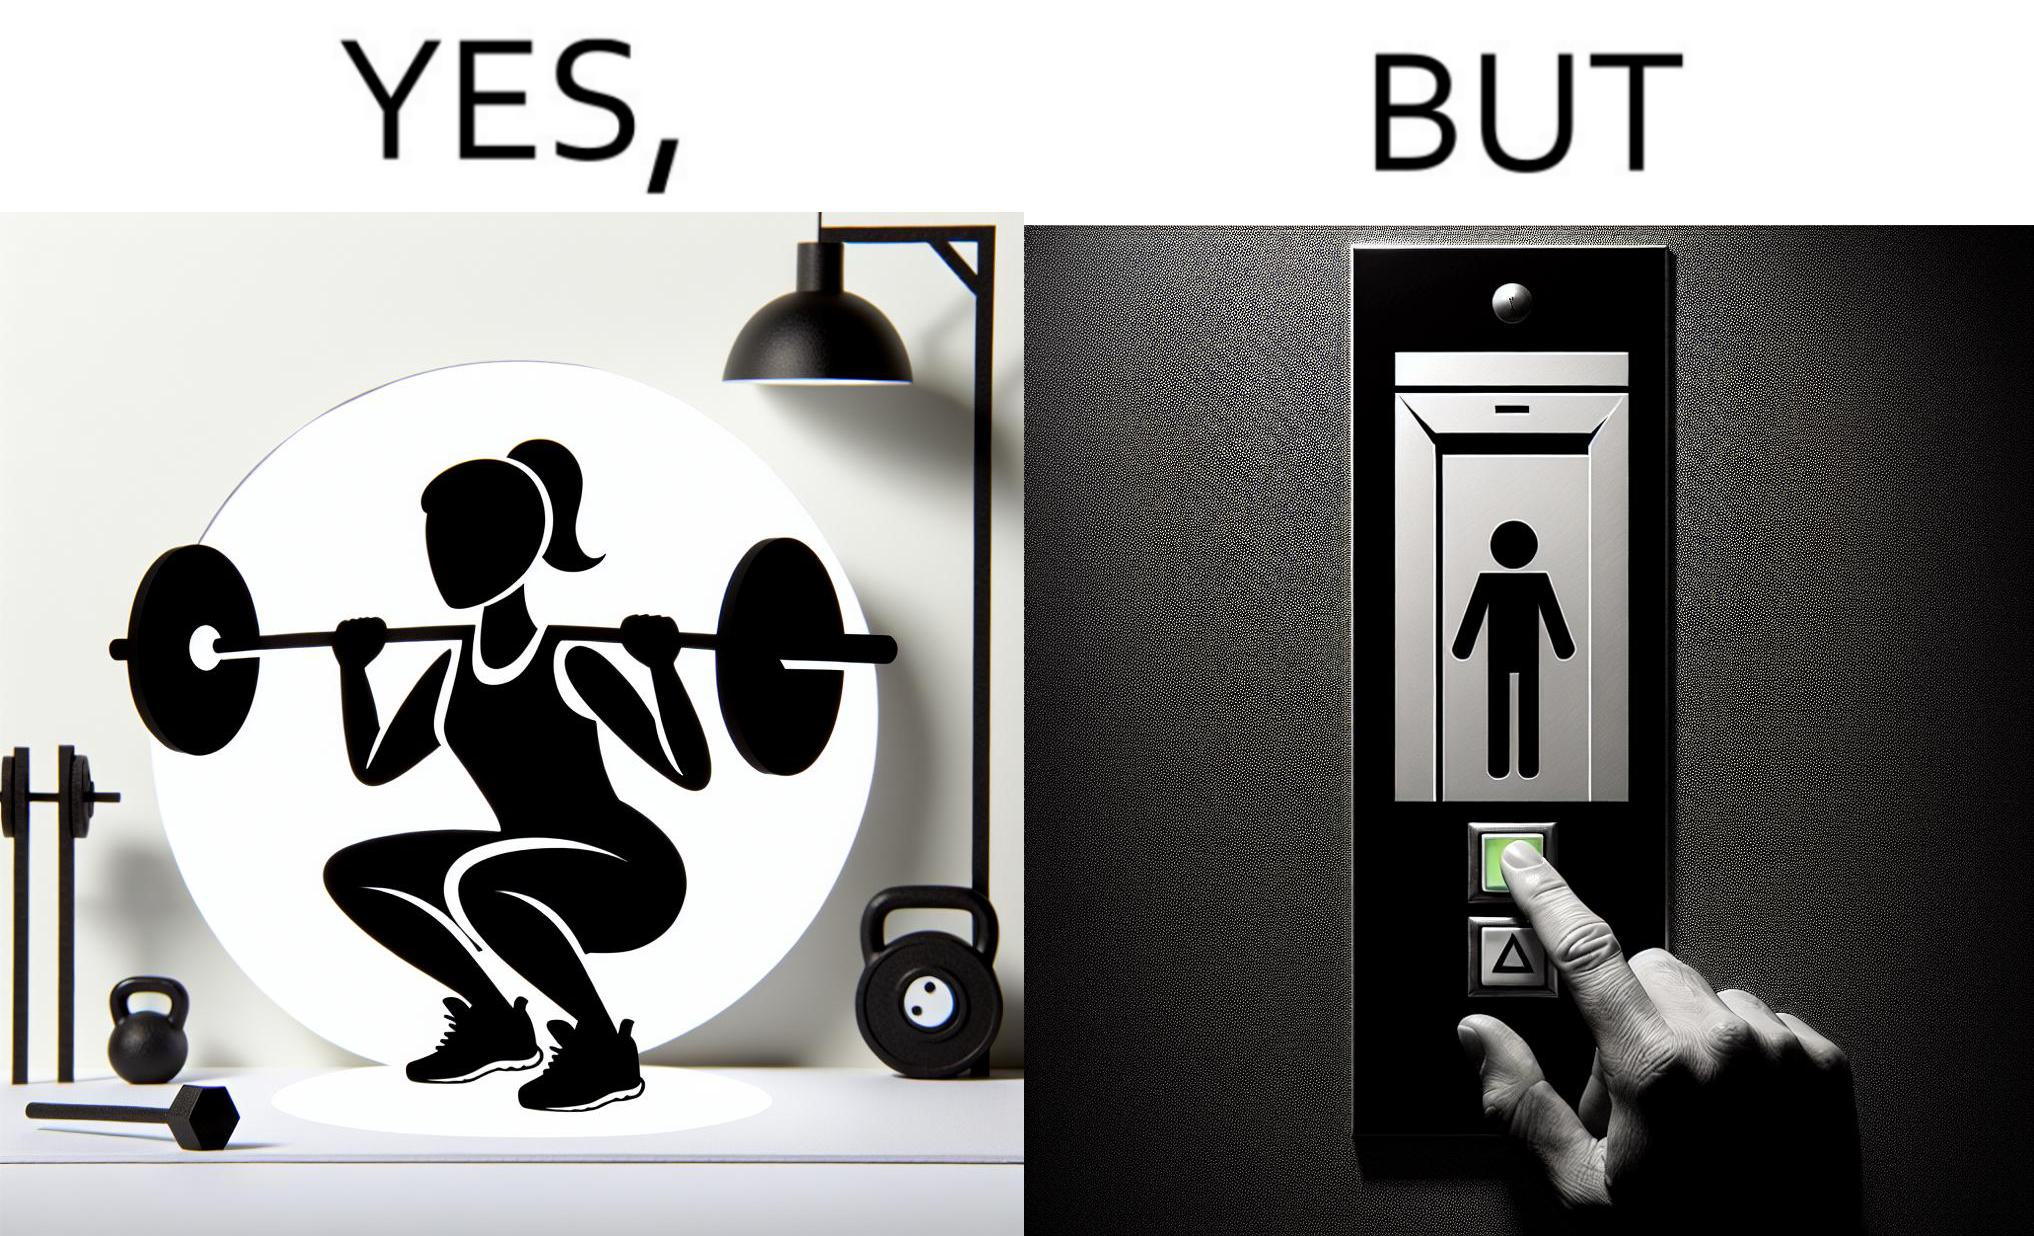Compare the left and right sides of this image. In the left part of the image: The image shows a women exercising with a bar bell in a gym. She is wearing a sport outfit. She is crouching down on one leg doing a single leg squat with a bar bell. In the right part of the image: The image shows the control panel inside of an elevator. The indicator for the first floor is green which means the button for the first floor was pressed. A hand is about to press the button for the second floor. 